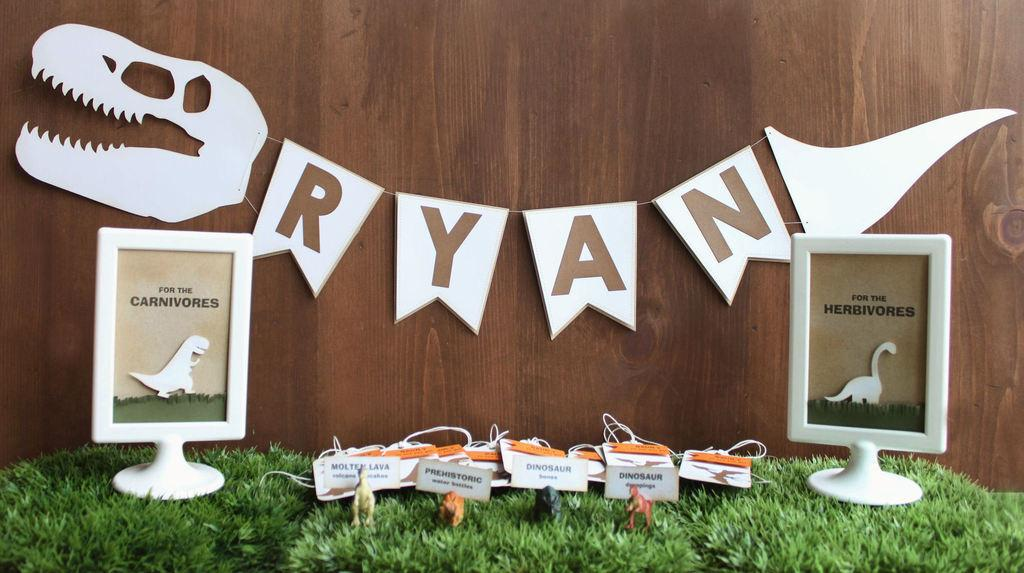What is hanging on the wooden wall in the image? Papers are hanging on a wooden wall in the image. How many frames can be seen in the image? There are two frames visible in the image. What type of objects are present in the image? Toys are present in the image. What color is the grass in the image? The grass is green in color. Can you tell me how many times the beginner jumps in the image? There is no person jumping in the image, nor is there any reference to a beginner. 